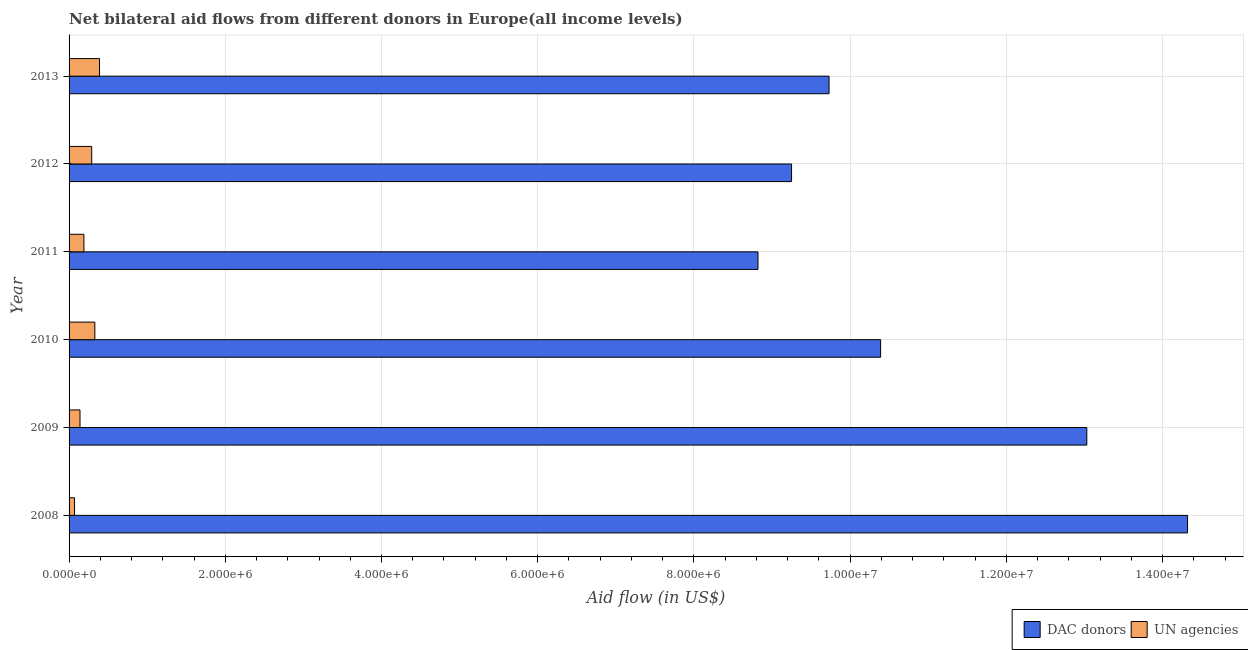How many different coloured bars are there?
Offer a terse response. 2. Are the number of bars per tick equal to the number of legend labels?
Keep it short and to the point. Yes. Are the number of bars on each tick of the Y-axis equal?
Provide a succinct answer. Yes. How many bars are there on the 4th tick from the bottom?
Your answer should be compact. 2. What is the label of the 3rd group of bars from the top?
Keep it short and to the point. 2011. In how many cases, is the number of bars for a given year not equal to the number of legend labels?
Offer a terse response. 0. What is the aid flow from dac donors in 2009?
Give a very brief answer. 1.30e+07. Across all years, what is the maximum aid flow from un agencies?
Provide a succinct answer. 3.90e+05. Across all years, what is the minimum aid flow from un agencies?
Keep it short and to the point. 7.00e+04. In which year was the aid flow from dac donors maximum?
Ensure brevity in your answer.  2008. What is the total aid flow from dac donors in the graph?
Your answer should be compact. 6.55e+07. What is the difference between the aid flow from un agencies in 2008 and that in 2010?
Keep it short and to the point. -2.60e+05. What is the difference between the aid flow from un agencies in 2008 and the aid flow from dac donors in 2010?
Keep it short and to the point. -1.03e+07. What is the average aid flow from dac donors per year?
Offer a terse response. 1.09e+07. In the year 2011, what is the difference between the aid flow from dac donors and aid flow from un agencies?
Your answer should be compact. 8.63e+06. What is the ratio of the aid flow from dac donors in 2012 to that in 2013?
Provide a succinct answer. 0.95. Is the aid flow from un agencies in 2010 less than that in 2011?
Offer a terse response. No. What is the difference between the highest and the second highest aid flow from dac donors?
Provide a short and direct response. 1.29e+06. What is the difference between the highest and the lowest aid flow from un agencies?
Give a very brief answer. 3.20e+05. In how many years, is the aid flow from dac donors greater than the average aid flow from dac donors taken over all years?
Your answer should be very brief. 2. Is the sum of the aid flow from dac donors in 2009 and 2012 greater than the maximum aid flow from un agencies across all years?
Your answer should be very brief. Yes. What does the 1st bar from the top in 2012 represents?
Keep it short and to the point. UN agencies. What does the 1st bar from the bottom in 2013 represents?
Give a very brief answer. DAC donors. Are all the bars in the graph horizontal?
Give a very brief answer. Yes. Does the graph contain any zero values?
Your answer should be compact. No. Does the graph contain grids?
Make the answer very short. Yes. How many legend labels are there?
Provide a succinct answer. 2. What is the title of the graph?
Your response must be concise. Net bilateral aid flows from different donors in Europe(all income levels). Does "Female" appear as one of the legend labels in the graph?
Ensure brevity in your answer.  No. What is the label or title of the X-axis?
Offer a terse response. Aid flow (in US$). What is the Aid flow (in US$) of DAC donors in 2008?
Your answer should be compact. 1.43e+07. What is the Aid flow (in US$) of DAC donors in 2009?
Offer a very short reply. 1.30e+07. What is the Aid flow (in US$) of DAC donors in 2010?
Ensure brevity in your answer.  1.04e+07. What is the Aid flow (in US$) in UN agencies in 2010?
Keep it short and to the point. 3.30e+05. What is the Aid flow (in US$) of DAC donors in 2011?
Your response must be concise. 8.82e+06. What is the Aid flow (in US$) of UN agencies in 2011?
Ensure brevity in your answer.  1.90e+05. What is the Aid flow (in US$) in DAC donors in 2012?
Your answer should be very brief. 9.25e+06. What is the Aid flow (in US$) in UN agencies in 2012?
Your answer should be compact. 2.90e+05. What is the Aid flow (in US$) in DAC donors in 2013?
Your response must be concise. 9.73e+06. Across all years, what is the maximum Aid flow (in US$) in DAC donors?
Keep it short and to the point. 1.43e+07. Across all years, what is the minimum Aid flow (in US$) of DAC donors?
Provide a short and direct response. 8.82e+06. What is the total Aid flow (in US$) in DAC donors in the graph?
Offer a very short reply. 6.55e+07. What is the total Aid flow (in US$) in UN agencies in the graph?
Your response must be concise. 1.41e+06. What is the difference between the Aid flow (in US$) in DAC donors in 2008 and that in 2009?
Make the answer very short. 1.29e+06. What is the difference between the Aid flow (in US$) in UN agencies in 2008 and that in 2009?
Your response must be concise. -7.00e+04. What is the difference between the Aid flow (in US$) of DAC donors in 2008 and that in 2010?
Provide a short and direct response. 3.93e+06. What is the difference between the Aid flow (in US$) of DAC donors in 2008 and that in 2011?
Your response must be concise. 5.50e+06. What is the difference between the Aid flow (in US$) in DAC donors in 2008 and that in 2012?
Offer a terse response. 5.07e+06. What is the difference between the Aid flow (in US$) in UN agencies in 2008 and that in 2012?
Give a very brief answer. -2.20e+05. What is the difference between the Aid flow (in US$) in DAC donors in 2008 and that in 2013?
Offer a very short reply. 4.59e+06. What is the difference between the Aid flow (in US$) of UN agencies in 2008 and that in 2013?
Make the answer very short. -3.20e+05. What is the difference between the Aid flow (in US$) in DAC donors in 2009 and that in 2010?
Provide a succinct answer. 2.64e+06. What is the difference between the Aid flow (in US$) in UN agencies in 2009 and that in 2010?
Your response must be concise. -1.90e+05. What is the difference between the Aid flow (in US$) in DAC donors in 2009 and that in 2011?
Make the answer very short. 4.21e+06. What is the difference between the Aid flow (in US$) of DAC donors in 2009 and that in 2012?
Make the answer very short. 3.78e+06. What is the difference between the Aid flow (in US$) of UN agencies in 2009 and that in 2012?
Give a very brief answer. -1.50e+05. What is the difference between the Aid flow (in US$) of DAC donors in 2009 and that in 2013?
Offer a very short reply. 3.30e+06. What is the difference between the Aid flow (in US$) in UN agencies in 2009 and that in 2013?
Keep it short and to the point. -2.50e+05. What is the difference between the Aid flow (in US$) of DAC donors in 2010 and that in 2011?
Offer a terse response. 1.57e+06. What is the difference between the Aid flow (in US$) of UN agencies in 2010 and that in 2011?
Provide a succinct answer. 1.40e+05. What is the difference between the Aid flow (in US$) in DAC donors in 2010 and that in 2012?
Give a very brief answer. 1.14e+06. What is the difference between the Aid flow (in US$) in UN agencies in 2010 and that in 2012?
Offer a very short reply. 4.00e+04. What is the difference between the Aid flow (in US$) of DAC donors in 2010 and that in 2013?
Make the answer very short. 6.60e+05. What is the difference between the Aid flow (in US$) in UN agencies in 2010 and that in 2013?
Your answer should be very brief. -6.00e+04. What is the difference between the Aid flow (in US$) in DAC donors in 2011 and that in 2012?
Ensure brevity in your answer.  -4.30e+05. What is the difference between the Aid flow (in US$) in DAC donors in 2011 and that in 2013?
Ensure brevity in your answer.  -9.10e+05. What is the difference between the Aid flow (in US$) in UN agencies in 2011 and that in 2013?
Offer a terse response. -2.00e+05. What is the difference between the Aid flow (in US$) in DAC donors in 2012 and that in 2013?
Your response must be concise. -4.80e+05. What is the difference between the Aid flow (in US$) of DAC donors in 2008 and the Aid flow (in US$) of UN agencies in 2009?
Ensure brevity in your answer.  1.42e+07. What is the difference between the Aid flow (in US$) in DAC donors in 2008 and the Aid flow (in US$) in UN agencies in 2010?
Your response must be concise. 1.40e+07. What is the difference between the Aid flow (in US$) of DAC donors in 2008 and the Aid flow (in US$) of UN agencies in 2011?
Provide a succinct answer. 1.41e+07. What is the difference between the Aid flow (in US$) in DAC donors in 2008 and the Aid flow (in US$) in UN agencies in 2012?
Keep it short and to the point. 1.40e+07. What is the difference between the Aid flow (in US$) in DAC donors in 2008 and the Aid flow (in US$) in UN agencies in 2013?
Offer a very short reply. 1.39e+07. What is the difference between the Aid flow (in US$) in DAC donors in 2009 and the Aid flow (in US$) in UN agencies in 2010?
Your answer should be compact. 1.27e+07. What is the difference between the Aid flow (in US$) in DAC donors in 2009 and the Aid flow (in US$) in UN agencies in 2011?
Offer a very short reply. 1.28e+07. What is the difference between the Aid flow (in US$) in DAC donors in 2009 and the Aid flow (in US$) in UN agencies in 2012?
Your answer should be compact. 1.27e+07. What is the difference between the Aid flow (in US$) of DAC donors in 2009 and the Aid flow (in US$) of UN agencies in 2013?
Ensure brevity in your answer.  1.26e+07. What is the difference between the Aid flow (in US$) in DAC donors in 2010 and the Aid flow (in US$) in UN agencies in 2011?
Offer a terse response. 1.02e+07. What is the difference between the Aid flow (in US$) of DAC donors in 2010 and the Aid flow (in US$) of UN agencies in 2012?
Give a very brief answer. 1.01e+07. What is the difference between the Aid flow (in US$) in DAC donors in 2010 and the Aid flow (in US$) in UN agencies in 2013?
Your answer should be very brief. 1.00e+07. What is the difference between the Aid flow (in US$) in DAC donors in 2011 and the Aid flow (in US$) in UN agencies in 2012?
Offer a terse response. 8.53e+06. What is the difference between the Aid flow (in US$) of DAC donors in 2011 and the Aid flow (in US$) of UN agencies in 2013?
Your response must be concise. 8.43e+06. What is the difference between the Aid flow (in US$) in DAC donors in 2012 and the Aid flow (in US$) in UN agencies in 2013?
Your answer should be compact. 8.86e+06. What is the average Aid flow (in US$) in DAC donors per year?
Your answer should be compact. 1.09e+07. What is the average Aid flow (in US$) of UN agencies per year?
Your answer should be very brief. 2.35e+05. In the year 2008, what is the difference between the Aid flow (in US$) in DAC donors and Aid flow (in US$) in UN agencies?
Give a very brief answer. 1.42e+07. In the year 2009, what is the difference between the Aid flow (in US$) in DAC donors and Aid flow (in US$) in UN agencies?
Provide a succinct answer. 1.29e+07. In the year 2010, what is the difference between the Aid flow (in US$) of DAC donors and Aid flow (in US$) of UN agencies?
Your answer should be very brief. 1.01e+07. In the year 2011, what is the difference between the Aid flow (in US$) of DAC donors and Aid flow (in US$) of UN agencies?
Give a very brief answer. 8.63e+06. In the year 2012, what is the difference between the Aid flow (in US$) in DAC donors and Aid flow (in US$) in UN agencies?
Your answer should be compact. 8.96e+06. In the year 2013, what is the difference between the Aid flow (in US$) of DAC donors and Aid flow (in US$) of UN agencies?
Give a very brief answer. 9.34e+06. What is the ratio of the Aid flow (in US$) in DAC donors in 2008 to that in 2009?
Make the answer very short. 1.1. What is the ratio of the Aid flow (in US$) in DAC donors in 2008 to that in 2010?
Make the answer very short. 1.38. What is the ratio of the Aid flow (in US$) in UN agencies in 2008 to that in 2010?
Your response must be concise. 0.21. What is the ratio of the Aid flow (in US$) of DAC donors in 2008 to that in 2011?
Your answer should be compact. 1.62. What is the ratio of the Aid flow (in US$) in UN agencies in 2008 to that in 2011?
Give a very brief answer. 0.37. What is the ratio of the Aid flow (in US$) of DAC donors in 2008 to that in 2012?
Provide a short and direct response. 1.55. What is the ratio of the Aid flow (in US$) in UN agencies in 2008 to that in 2012?
Provide a succinct answer. 0.24. What is the ratio of the Aid flow (in US$) in DAC donors in 2008 to that in 2013?
Offer a terse response. 1.47. What is the ratio of the Aid flow (in US$) in UN agencies in 2008 to that in 2013?
Your response must be concise. 0.18. What is the ratio of the Aid flow (in US$) of DAC donors in 2009 to that in 2010?
Offer a terse response. 1.25. What is the ratio of the Aid flow (in US$) in UN agencies in 2009 to that in 2010?
Your answer should be very brief. 0.42. What is the ratio of the Aid flow (in US$) of DAC donors in 2009 to that in 2011?
Keep it short and to the point. 1.48. What is the ratio of the Aid flow (in US$) of UN agencies in 2009 to that in 2011?
Your answer should be very brief. 0.74. What is the ratio of the Aid flow (in US$) in DAC donors in 2009 to that in 2012?
Provide a short and direct response. 1.41. What is the ratio of the Aid flow (in US$) in UN agencies in 2009 to that in 2012?
Make the answer very short. 0.48. What is the ratio of the Aid flow (in US$) in DAC donors in 2009 to that in 2013?
Offer a terse response. 1.34. What is the ratio of the Aid flow (in US$) in UN agencies in 2009 to that in 2013?
Make the answer very short. 0.36. What is the ratio of the Aid flow (in US$) in DAC donors in 2010 to that in 2011?
Your answer should be very brief. 1.18. What is the ratio of the Aid flow (in US$) in UN agencies in 2010 to that in 2011?
Provide a succinct answer. 1.74. What is the ratio of the Aid flow (in US$) in DAC donors in 2010 to that in 2012?
Ensure brevity in your answer.  1.12. What is the ratio of the Aid flow (in US$) in UN agencies in 2010 to that in 2012?
Keep it short and to the point. 1.14. What is the ratio of the Aid flow (in US$) in DAC donors in 2010 to that in 2013?
Provide a short and direct response. 1.07. What is the ratio of the Aid flow (in US$) in UN agencies in 2010 to that in 2013?
Provide a short and direct response. 0.85. What is the ratio of the Aid flow (in US$) in DAC donors in 2011 to that in 2012?
Give a very brief answer. 0.95. What is the ratio of the Aid flow (in US$) in UN agencies in 2011 to that in 2012?
Give a very brief answer. 0.66. What is the ratio of the Aid flow (in US$) of DAC donors in 2011 to that in 2013?
Provide a short and direct response. 0.91. What is the ratio of the Aid flow (in US$) of UN agencies in 2011 to that in 2013?
Offer a very short reply. 0.49. What is the ratio of the Aid flow (in US$) in DAC donors in 2012 to that in 2013?
Provide a short and direct response. 0.95. What is the ratio of the Aid flow (in US$) of UN agencies in 2012 to that in 2013?
Your answer should be compact. 0.74. What is the difference between the highest and the second highest Aid flow (in US$) of DAC donors?
Ensure brevity in your answer.  1.29e+06. What is the difference between the highest and the lowest Aid flow (in US$) in DAC donors?
Keep it short and to the point. 5.50e+06. 